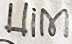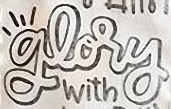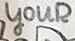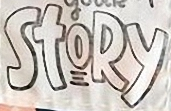What text is displayed in these images sequentially, separated by a semicolon? Him; glory; youR; StoRy 